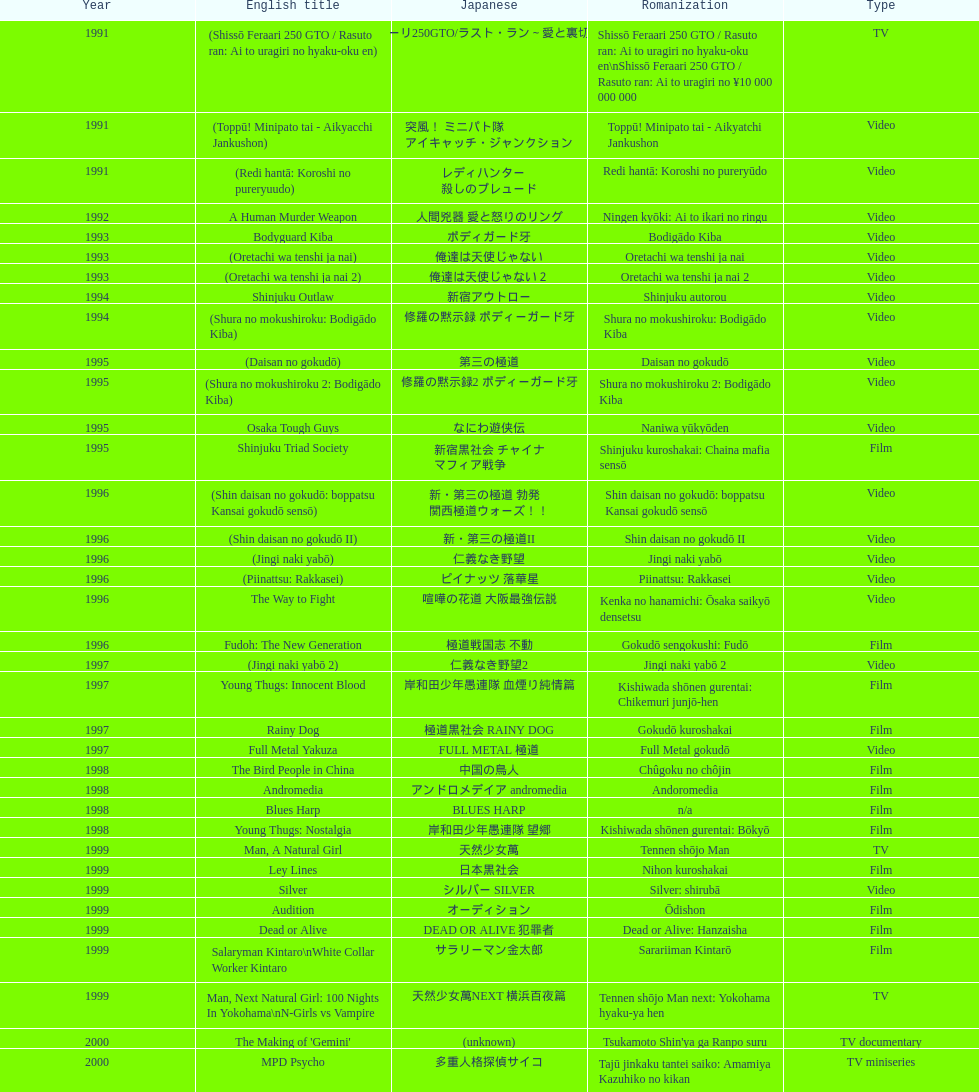Mention a motion picture that came out before 199 Shinjuku Triad Society. 